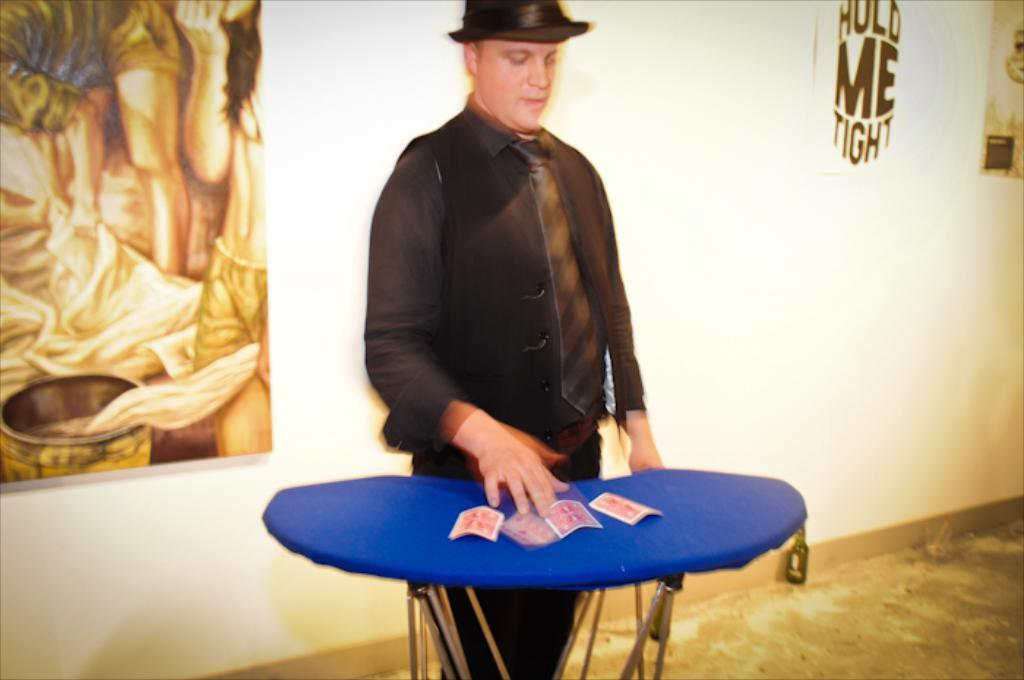What is located in the middle of the image? There is a table in the middle of the image. What is on the table in the image? Cards are present on the table. Can you describe the person behind the table? There is a man behind the table, and he is wearing a hat. What can be seen behind the man? There is a wall behind the man, and there is a frame and a poster on the wall. What type of string is being used to hold the cards together in the image? There is no string visible in the image; the cards are simply placed on the table. 